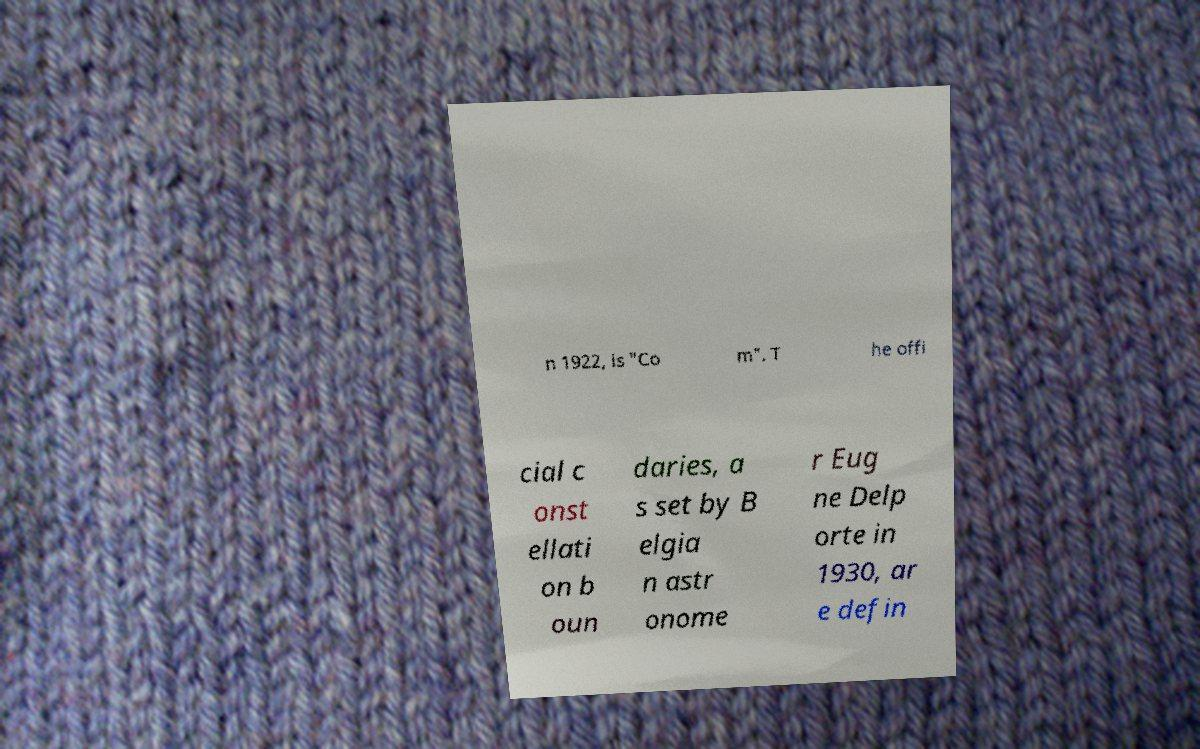Can you read and provide the text displayed in the image?This photo seems to have some interesting text. Can you extract and type it out for me? n 1922, is "Co m". T he offi cial c onst ellati on b oun daries, a s set by B elgia n astr onome r Eug ne Delp orte in 1930, ar e defin 